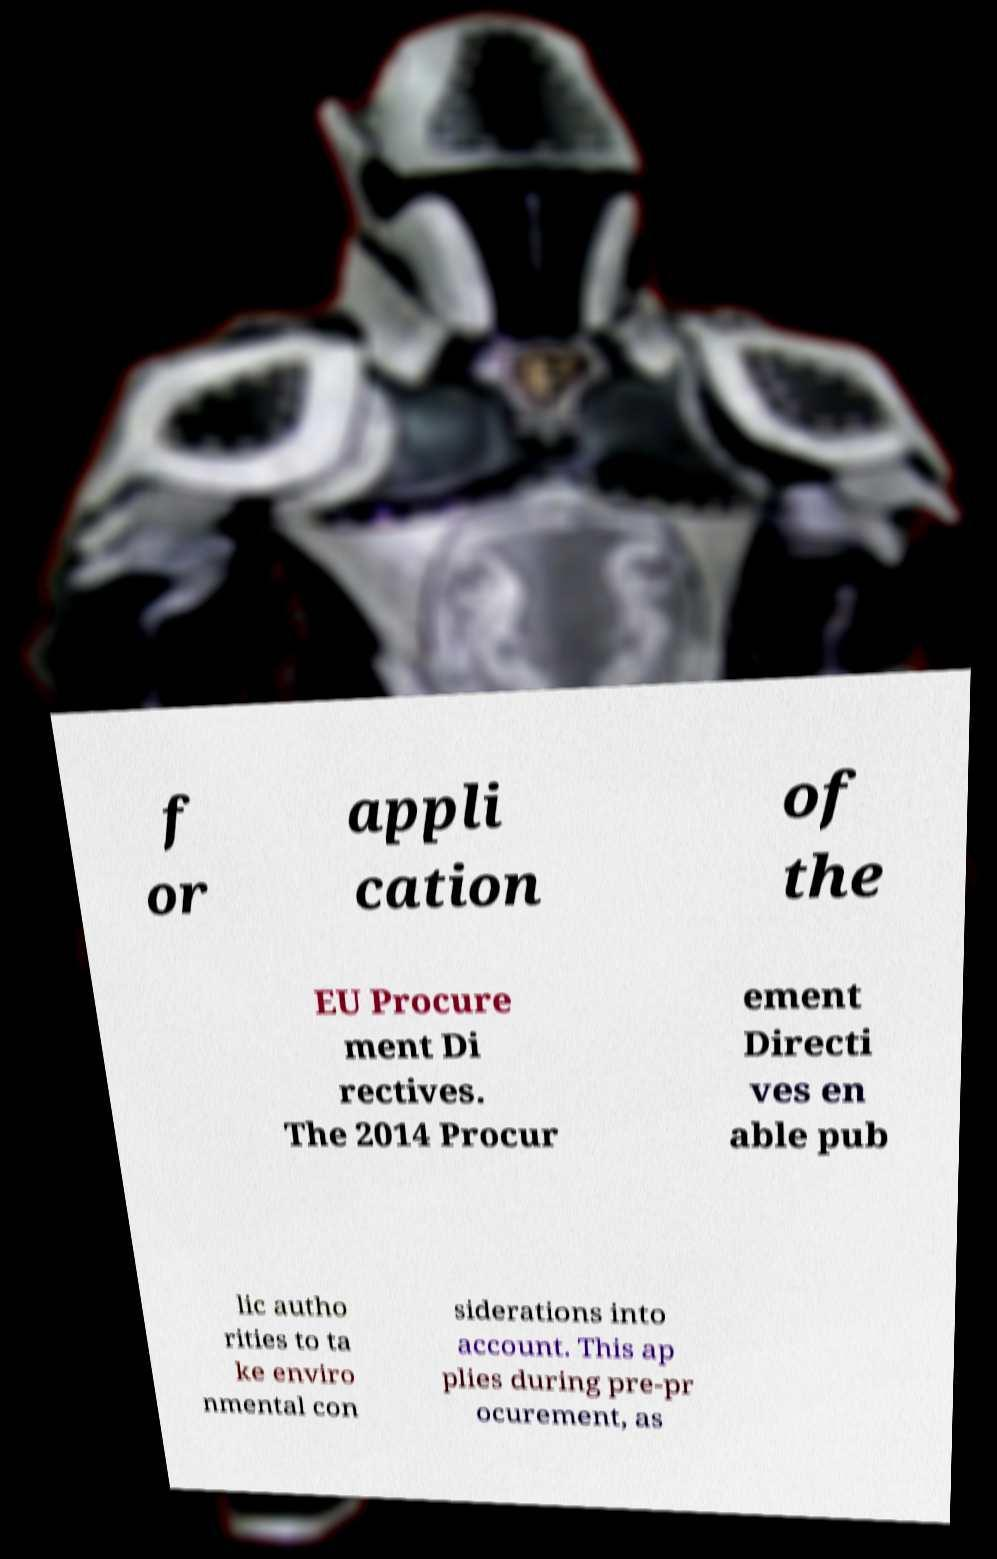Could you extract and type out the text from this image? f or appli cation of the EU Procure ment Di rectives. The 2014 Procur ement Directi ves en able pub lic autho rities to ta ke enviro nmental con siderations into account. This ap plies during pre-pr ocurement, as 